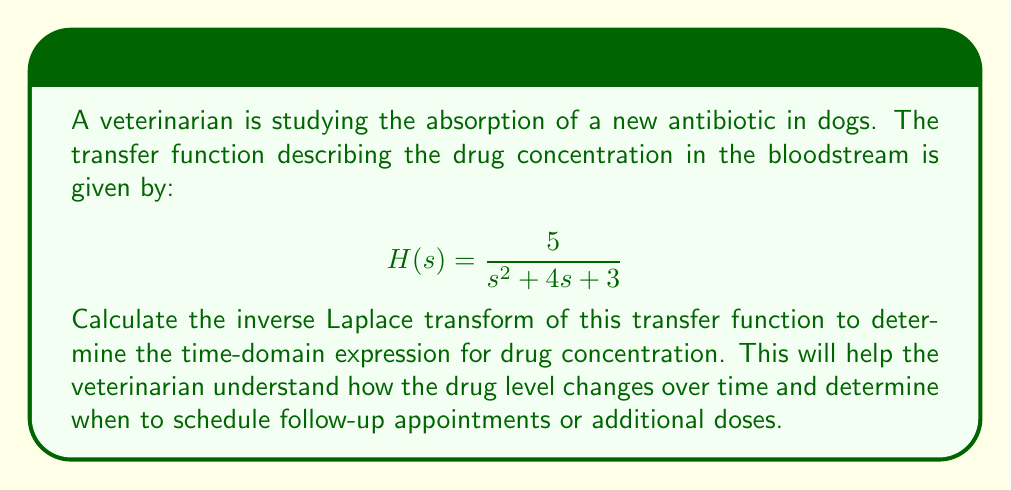Solve this math problem. To find the inverse Laplace transform, we'll follow these steps:

1) First, recognize that this transfer function is in the form:
   $$\frac{A}{s^2 + 2\alpha s + \omega^2}$$
   where $A = 5$, $2\alpha = 4$ (so $\alpha = 2$), and $\omega^2 = 3$.

2) The general inverse Laplace transform for this form is:
   $$\mathcal{L}^{-1}\left\{\frac{A}{s^2 + 2\alpha s + \omega^2}\right\} = \frac{A}{\sqrt{\omega^2 - \alpha^2}}e^{-\alpha t}\sin(\sqrt{\omega^2 - \alpha^2}t)$$

3) Calculate $\sqrt{\omega^2 - \alpha^2}$:
   $$\sqrt{\omega^2 - \alpha^2} = \sqrt{3 - 2^2} = \sqrt{3 - 4} = \sqrt{-1} = i$$

4) Substitute the values into the general form:
   $$\frac{5}{i}e^{-2t}\sin(it)$$

5) Simplify using Euler's formula ($\sin(ix) = i\sinh(x)$):
   $$\frac{5}{i}e^{-2t}(i\sinh(t)) = 5e^{-2t}\sinh(t)$$

This gives us the time-domain expression for the drug concentration.
Answer: $5e^{-2t}\sinh(t)$ 